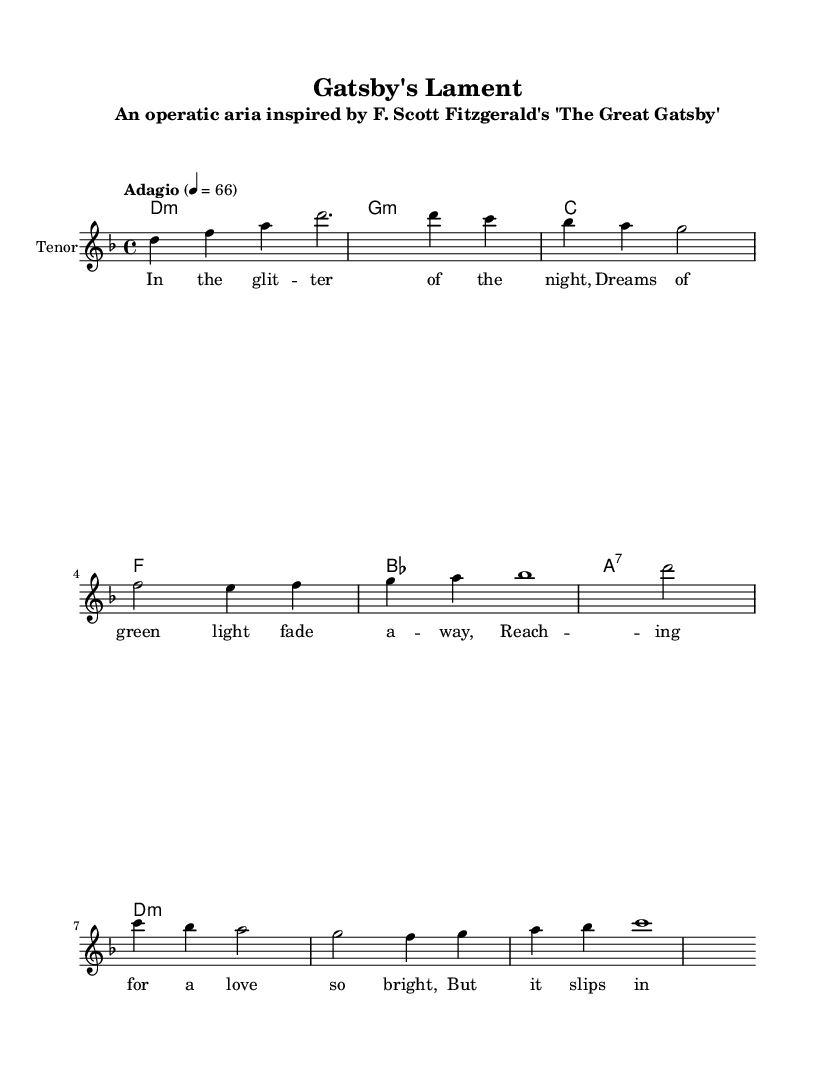What is the key signature of this music? The key signature is D minor, indicated by one flat in the sheet music.
Answer: D minor What is the time signature of the piece? The time signature is 4/4, which means there are four beats per measure and the quarter note gets one beat.
Answer: 4/4 What is the tempo marking for this score? The tempo marking is "Adagio," which indicates a slow tempo.
Answer: Adagio How many measures are in the melody section? The melody section contains eight measures, counted from the introduction through the chorus.
Answer: 8 What type of vocal part is assigned to the melody? The melody is assigned to the tenor voice, as indicated in the staff label.
Answer: Tenor What is the emotional theme conveyed in the chorus? The chorus suggests longing and nostalgia as expressed in the lyrics about Daisy and a lost world.
Answer: Longing Which literary work inspired this operatic aria? The operatic aria is inspired by F. Scott Fitzgerald's "The Great Gatsby," as mentioned in the subtitle.
Answer: The Great Gatsby 